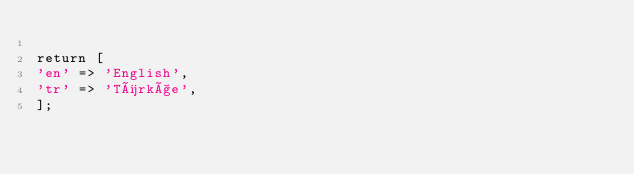<code> <loc_0><loc_0><loc_500><loc_500><_PHP_>
return [
'en' => 'English',
'tr' => 'Türkçe',
];
</code> 